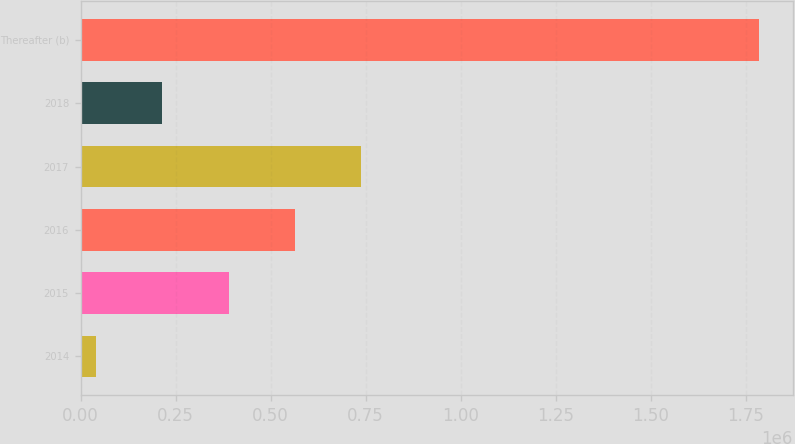<chart> <loc_0><loc_0><loc_500><loc_500><bar_chart><fcel>2014<fcel>2015<fcel>2016<fcel>2017<fcel>2018<fcel>Thereafter (b)<nl><fcel>40458<fcel>389429<fcel>563915<fcel>738400<fcel>214944<fcel>1.78531e+06<nl></chart> 